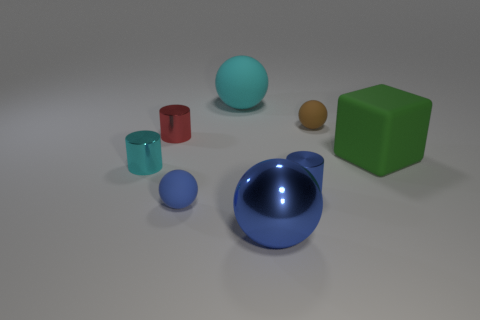There is a small red metal cylinder behind the cube; is there a cylinder that is in front of it?
Your answer should be compact. Yes. What color is the other big object that is the same material as the red thing?
Your answer should be compact. Blue. Is the number of large blue metallic balls greater than the number of tiny gray rubber spheres?
Keep it short and to the point. Yes. How many things are blue metal things that are behind the tiny blue rubber thing or big gray shiny objects?
Provide a succinct answer. 1. Is there a thing of the same size as the cyan ball?
Offer a very short reply. Yes. Is the number of tiny spheres less than the number of big objects?
Offer a very short reply. Yes. How many cylinders are either small gray rubber things or large cyan objects?
Your answer should be compact. 0. What number of cubes are the same color as the large metal thing?
Give a very brief answer. 0. How big is the sphere that is both to the right of the large cyan ball and in front of the matte cube?
Your answer should be very brief. Large. Are there fewer red shiny things behind the red shiny cylinder than large red shiny cubes?
Offer a terse response. No. 